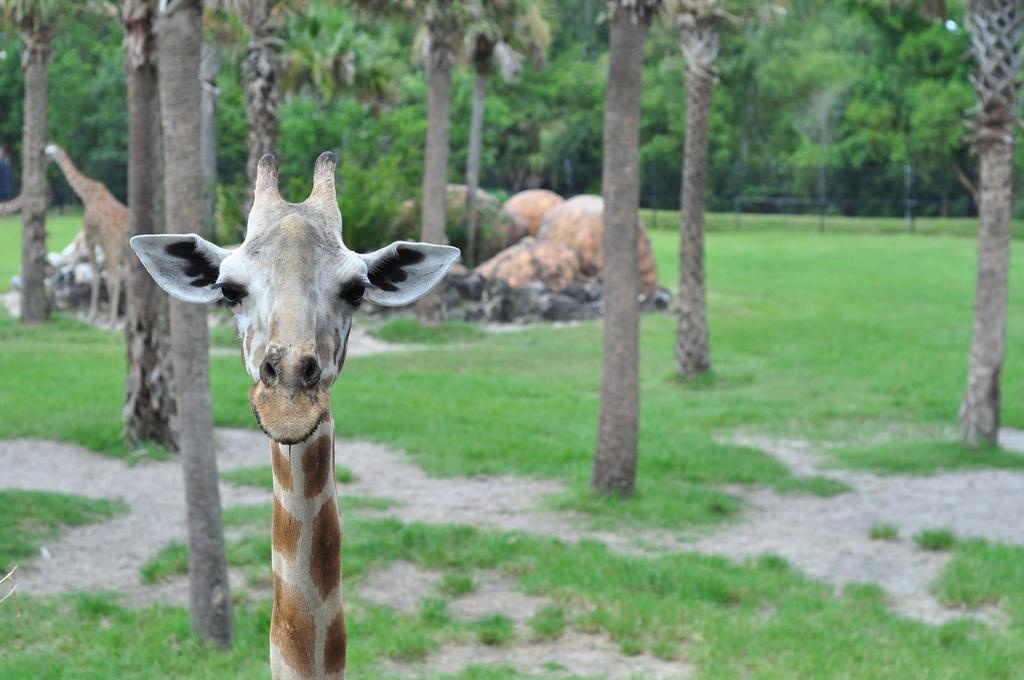Please provide a concise description of this image. In this image, we can see giraffes and in the background, there are trees, fence and rocks. At the bottom, there is ground covered with grass. 